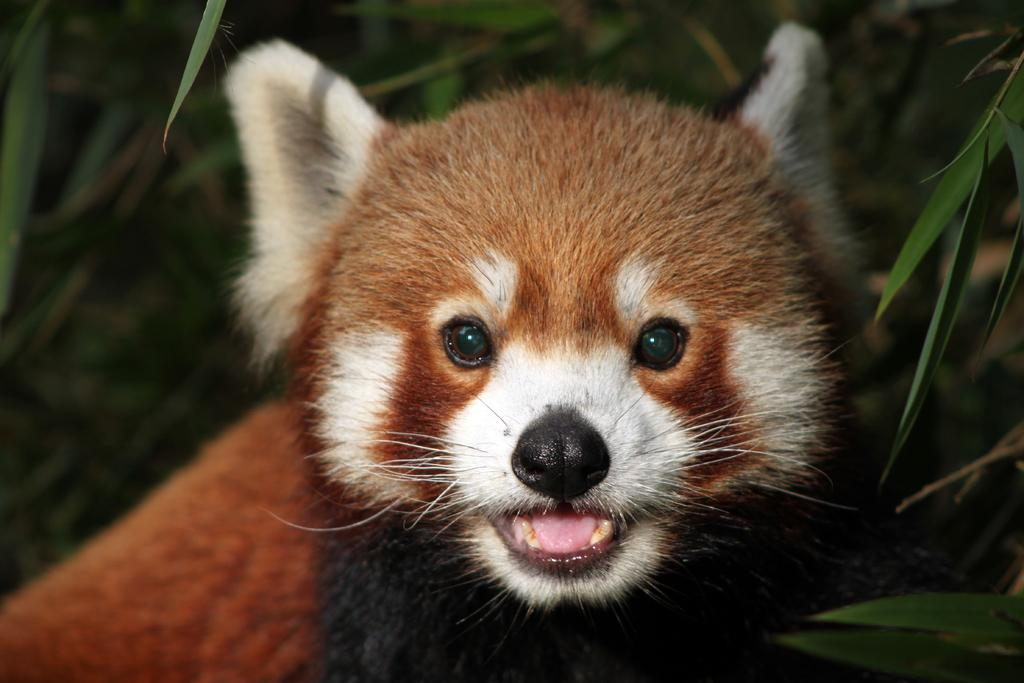What type of creature is in the picture? There is an animal in the picture. What color is the animal? The animal is brown in color. Are there any other colors on the animal? Yes, there is some white on its face. What type of vegetation can be seen in the image? There are grass plants visible in the image. What type of crime is the animal committing in the image? There is no crime being committed in the image; it is a picture of an animal with no indication of any criminal activity. 